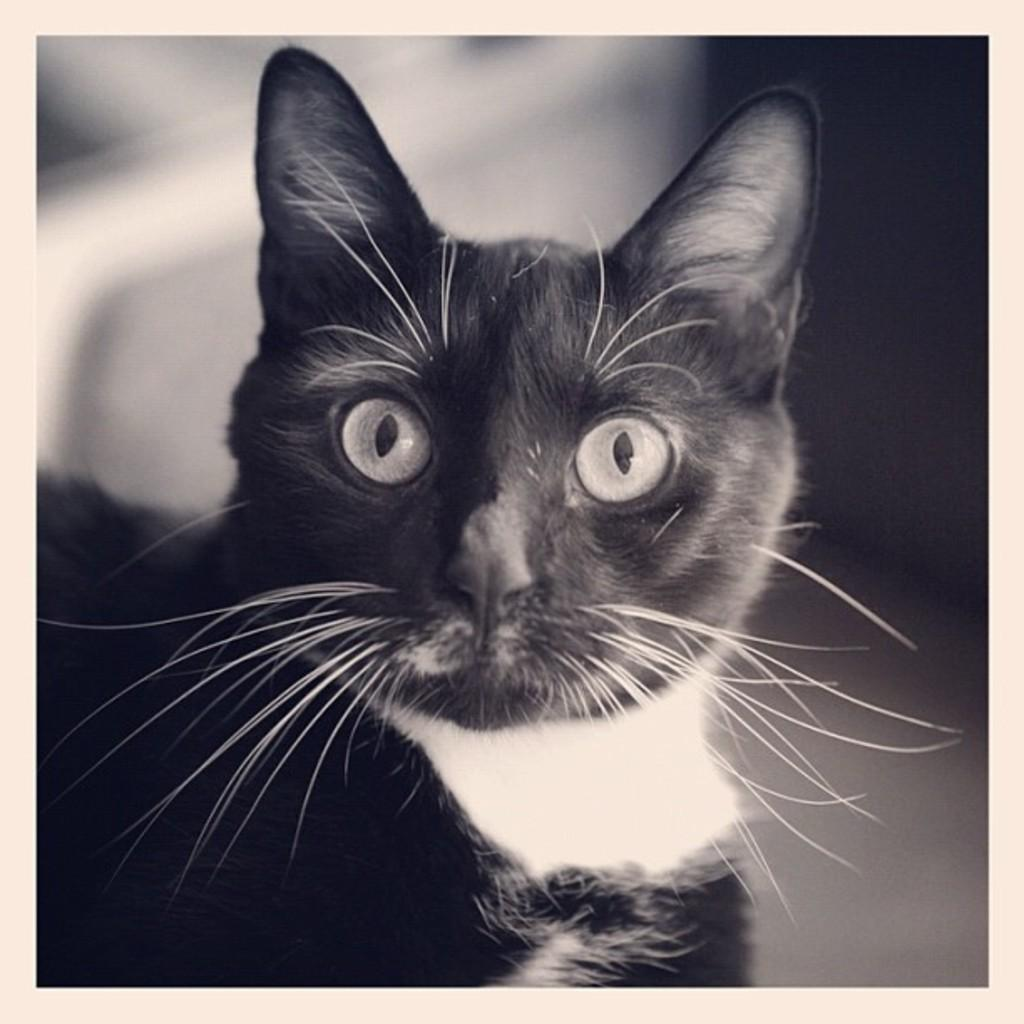What can be observed about the image? The image is edited. What type of animal is present in the image? There is a cat in the image. What type of boot is the cat wearing in the image? There is no boot present in the image; the cat is not wearing any footwear. What type of powder can be seen being used by the cat in the image? There is no powder present in the image, and the cat is not using any substance. 